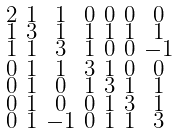Convert formula to latex. <formula><loc_0><loc_0><loc_500><loc_500>\begin{smallmatrix} 2 & 1 & 1 & 0 & 0 & 0 & 0 \\ 1 & 3 & 1 & 1 & 1 & 1 & 1 \\ 1 & 1 & 3 & 1 & 0 & 0 & - 1 \\ 0 & 1 & 1 & 3 & 1 & 0 & 0 \\ 0 & 1 & 0 & 1 & 3 & 1 & 1 \\ 0 & 1 & 0 & 0 & 1 & 3 & 1 \\ 0 & 1 & - 1 & 0 & 1 & 1 & 3 \end{smallmatrix}</formula> 